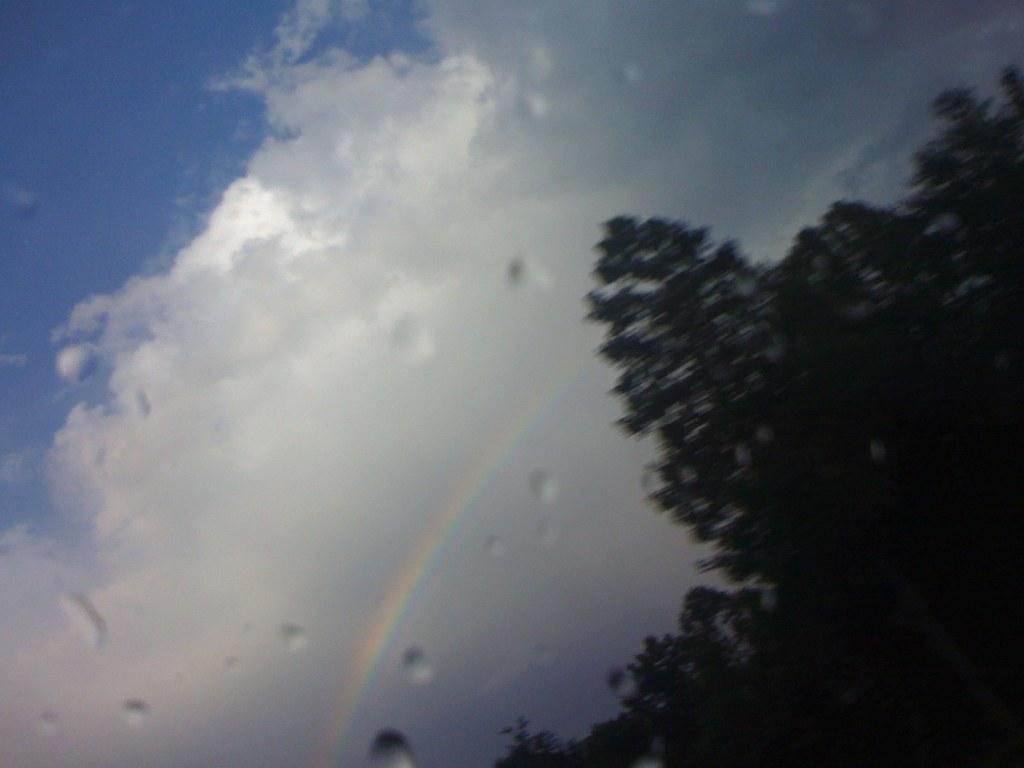What type of vegetation can be seen on the right side of the image? There are trees on the right side of the image. What is visible in the background of the image? There is a sky visible in the background of the image. What can be observed in the sky? Clouds are present in the sky, and a rainbow is visible. What type of credit can be seen on the trees in the image? There is no credit present on the trees in the image; they are simply trees. What color is the gold rainbow in the image? There is no gold rainbow in the image; the rainbow visible is composed of the colors of the spectrum. 